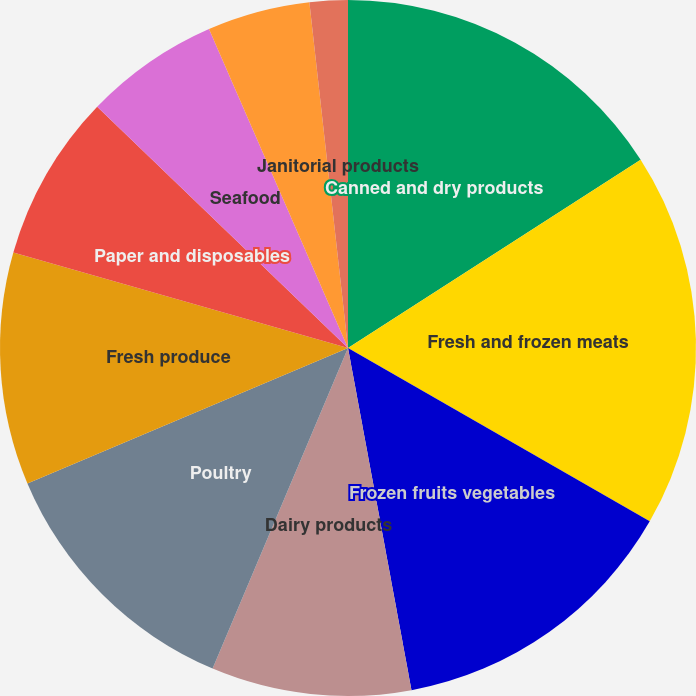Convert chart. <chart><loc_0><loc_0><loc_500><loc_500><pie_chart><fcel>Canned and dry products<fcel>Fresh and frozen meats<fcel>Frozen fruits vegetables<fcel>Dairy products<fcel>Poultry<fcel>Fresh produce<fcel>Paper and disposables<fcel>Seafood<fcel>Beverage products<fcel>Janitorial products<nl><fcel>15.9%<fcel>17.4%<fcel>13.78%<fcel>9.28%<fcel>12.28%<fcel>10.78%<fcel>7.77%<fcel>6.27%<fcel>4.77%<fcel>1.77%<nl></chart> 